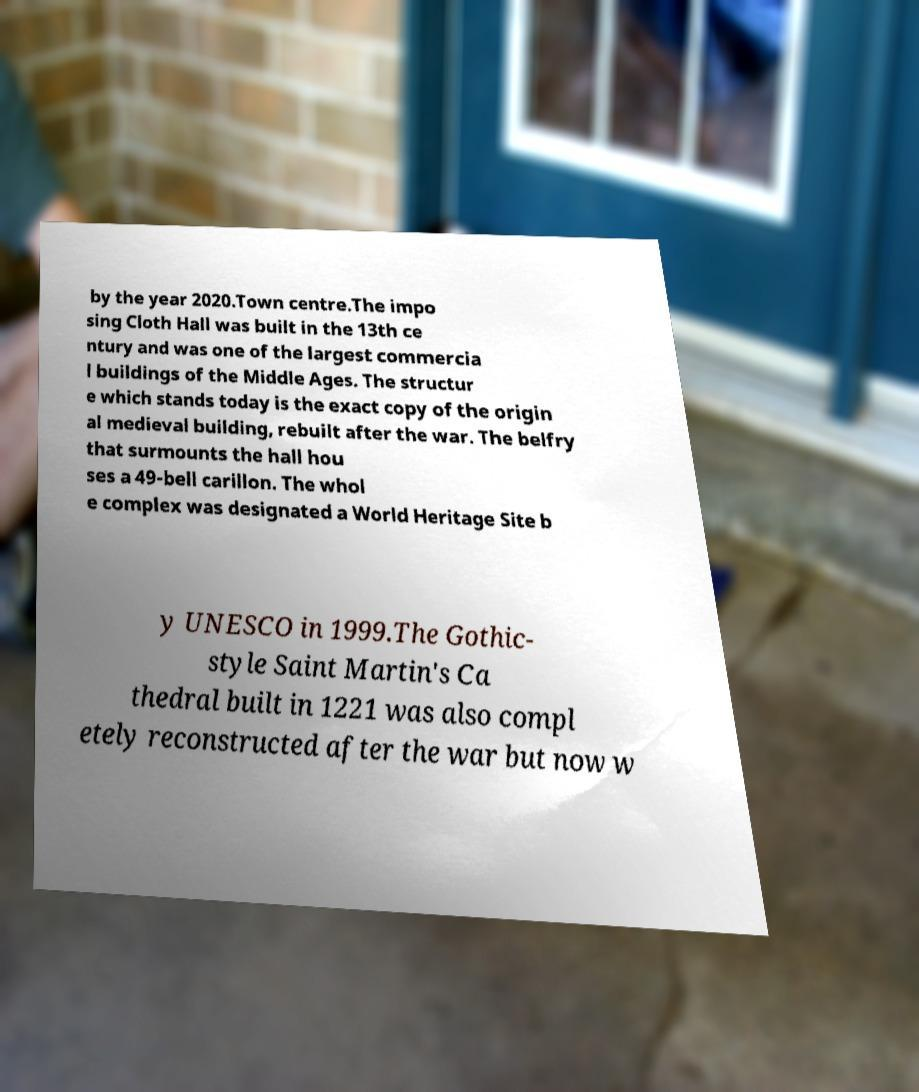Could you assist in decoding the text presented in this image and type it out clearly? by the year 2020.Town centre.The impo sing Cloth Hall was built in the 13th ce ntury and was one of the largest commercia l buildings of the Middle Ages. The structur e which stands today is the exact copy of the origin al medieval building, rebuilt after the war. The belfry that surmounts the hall hou ses a 49-bell carillon. The whol e complex was designated a World Heritage Site b y UNESCO in 1999.The Gothic- style Saint Martin's Ca thedral built in 1221 was also compl etely reconstructed after the war but now w 